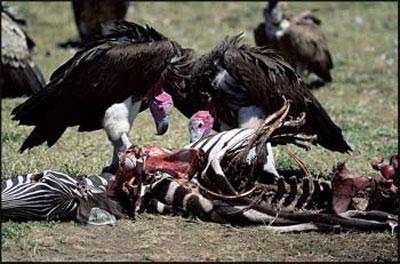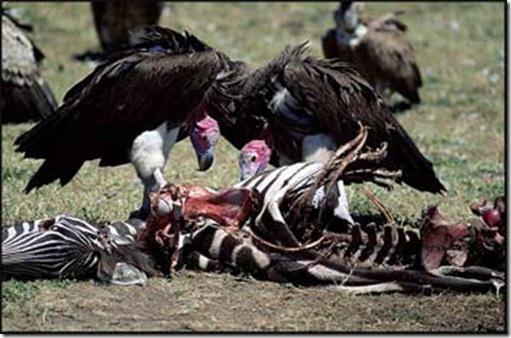The first image is the image on the left, the second image is the image on the right. Considering the images on both sides, is "rows of dead vultures are in the grass with at least one human in the backgroud" valid? Answer yes or no. No. The first image is the image on the left, the second image is the image on the right. Considering the images on both sides, is "there are humans in the pics" valid? Answer yes or no. No. 